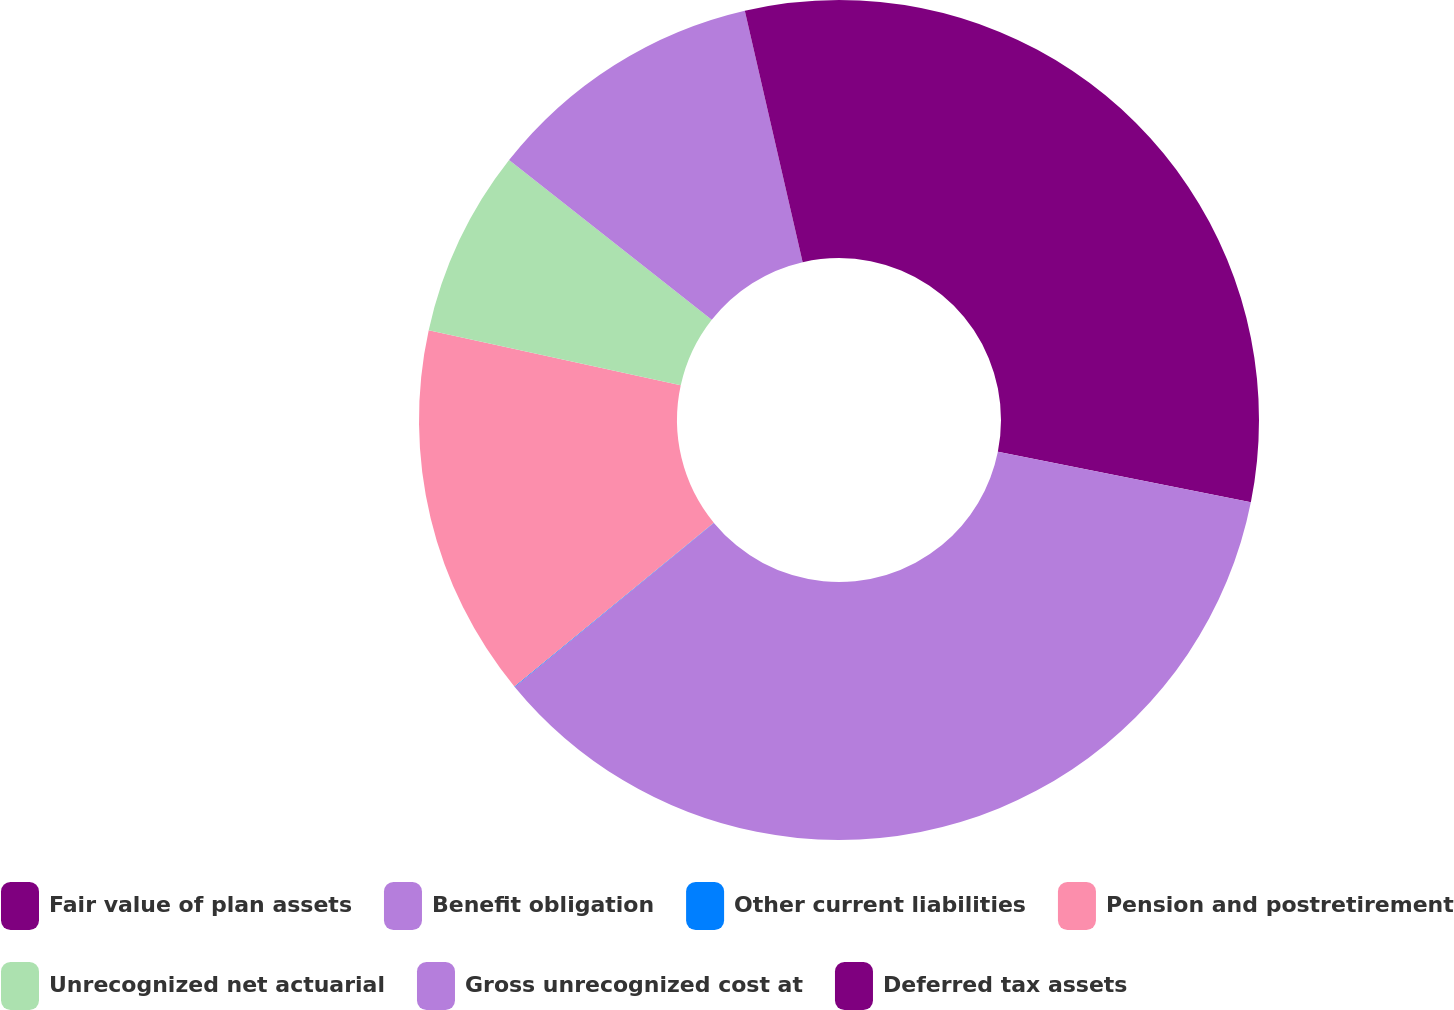Convert chart to OTSL. <chart><loc_0><loc_0><loc_500><loc_500><pie_chart><fcel>Fair value of plan assets<fcel>Benefit obligation<fcel>Other current liabilities<fcel>Pension and postretirement<fcel>Unrecognized net actuarial<fcel>Gross unrecognized cost at<fcel>Deferred tax assets<nl><fcel>28.14%<fcel>35.9%<fcel>0.02%<fcel>14.37%<fcel>7.19%<fcel>10.78%<fcel>3.6%<nl></chart> 